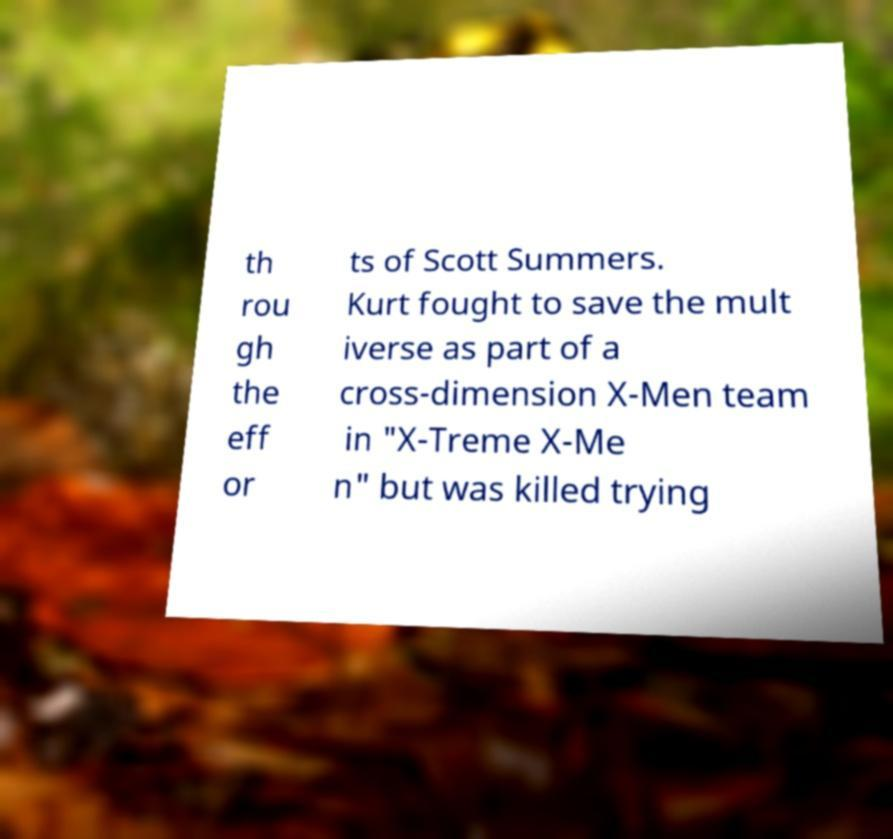For documentation purposes, I need the text within this image transcribed. Could you provide that? th rou gh the eff or ts of Scott Summers. Kurt fought to save the mult iverse as part of a cross-dimension X-Men team in "X-Treme X-Me n" but was killed trying 